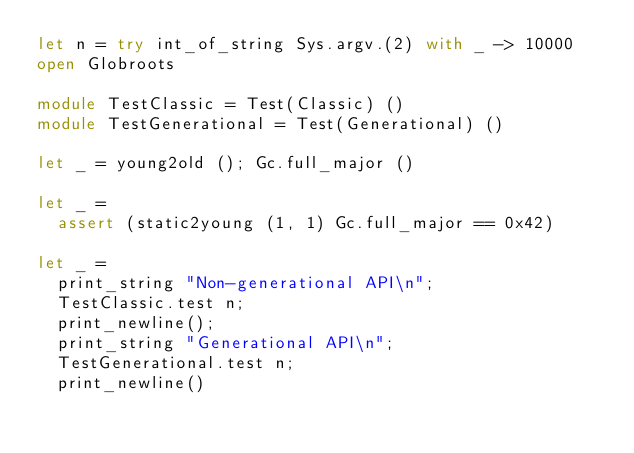Convert code to text. <code><loc_0><loc_0><loc_500><loc_500><_OCaml_>let n = try int_of_string Sys.argv.(2) with _ -> 10000
open Globroots

module TestClassic = Test(Classic) ()
module TestGenerational = Test(Generational) ()

let _ = young2old (); Gc.full_major ()

let _ =
  assert (static2young (1, 1) Gc.full_major == 0x42)

let _ =
  print_string "Non-generational API\n";
  TestClassic.test n;
  print_newline();
  print_string "Generational API\n";
  TestGenerational.test n;
  print_newline()
</code> 